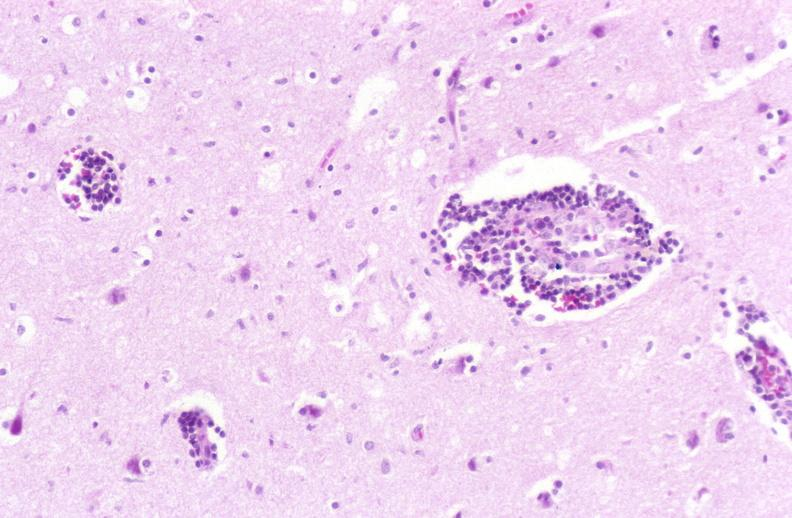does this image show brain, herpes encephalitis, perivascular cuffing?
Answer the question using a single word or phrase. Yes 